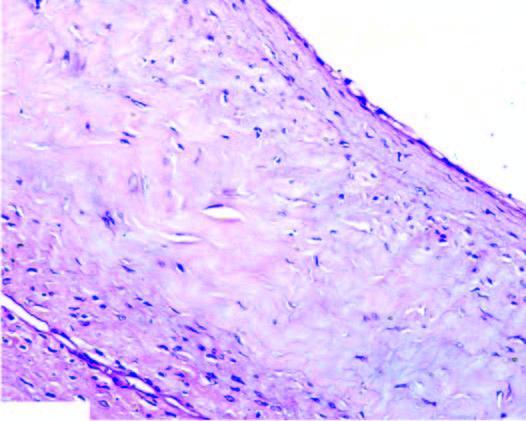what is the cyst wall composed of?
Answer the question using a single word or phrase. Dense connective tissue lined internally by flattened lining 